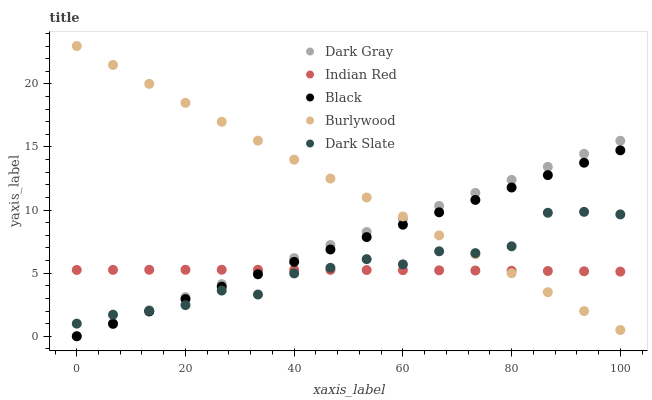Does Indian Red have the minimum area under the curve?
Answer yes or no. Yes. Does Burlywood have the maximum area under the curve?
Answer yes or no. Yes. Does Black have the minimum area under the curve?
Answer yes or no. No. Does Black have the maximum area under the curve?
Answer yes or no. No. Is Black the smoothest?
Answer yes or no. Yes. Is Dark Slate the roughest?
Answer yes or no. Yes. Is Burlywood the smoothest?
Answer yes or no. No. Is Burlywood the roughest?
Answer yes or no. No. Does Dark Gray have the lowest value?
Answer yes or no. Yes. Does Burlywood have the lowest value?
Answer yes or no. No. Does Burlywood have the highest value?
Answer yes or no. Yes. Does Black have the highest value?
Answer yes or no. No. Does Dark Gray intersect Burlywood?
Answer yes or no. Yes. Is Dark Gray less than Burlywood?
Answer yes or no. No. Is Dark Gray greater than Burlywood?
Answer yes or no. No. 